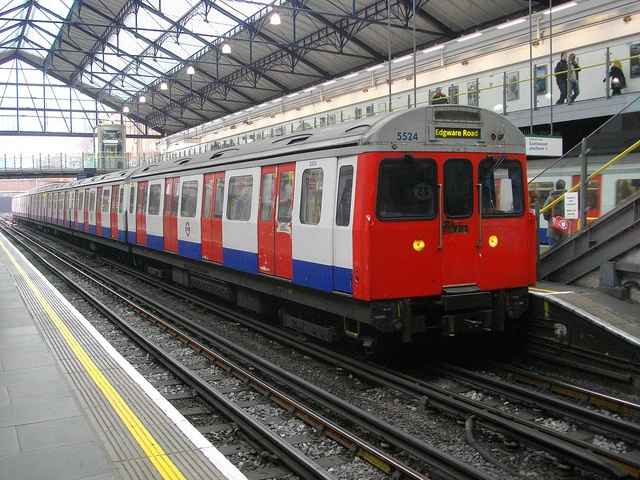Describe the objects in this image and their specific colors. I can see train in white, black, brown, darkgray, and gray tones, train in white, gray, darkgray, and black tones, people in white, gray, black, brown, and maroon tones, people in white, gray, and darkgray tones, and people in white and gray tones in this image. 